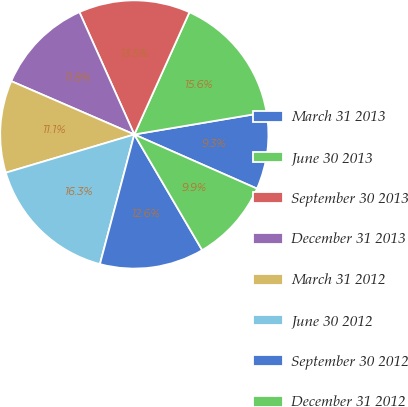<chart> <loc_0><loc_0><loc_500><loc_500><pie_chart><fcel>March 31 2013<fcel>June 30 2013<fcel>September 30 2013<fcel>December 31 2013<fcel>March 31 2012<fcel>June 30 2012<fcel>September 30 2012<fcel>December 31 2012<nl><fcel>9.27%<fcel>15.6%<fcel>13.45%<fcel>11.78%<fcel>11.11%<fcel>16.27%<fcel>12.57%<fcel>9.94%<nl></chart> 